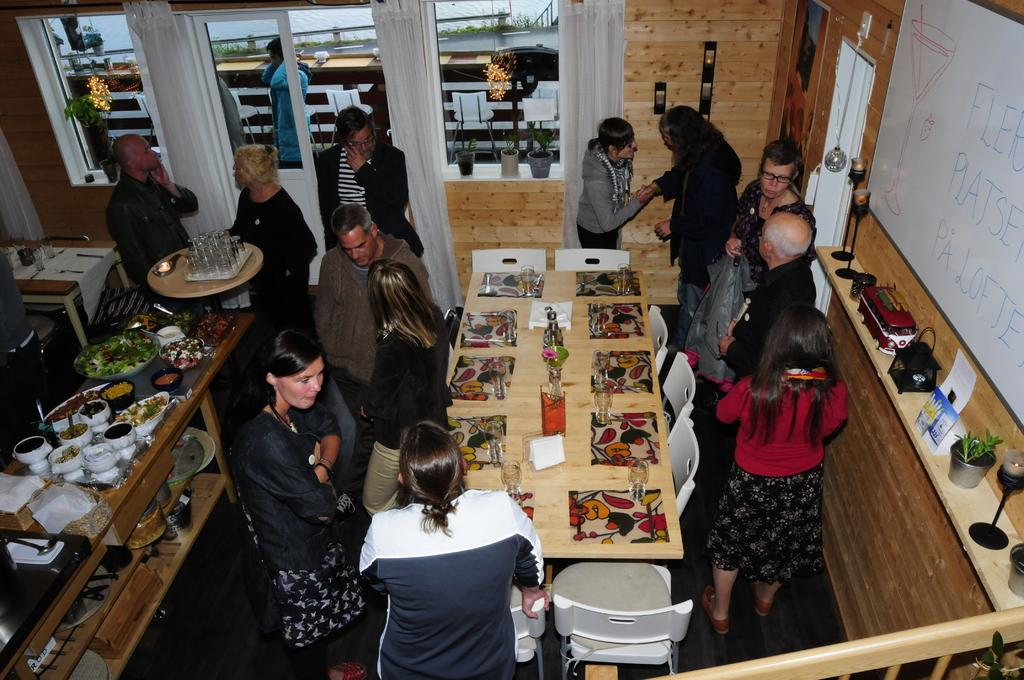What material is the room made of in the image? The room in the image is made of wood. How many people are people are present in the room? There are many people in the room. What furniture is present in the room? There are tables and chairs in the room. Can you see any feathers floating in the air in the image? No, there are no feathers visible in the image. 